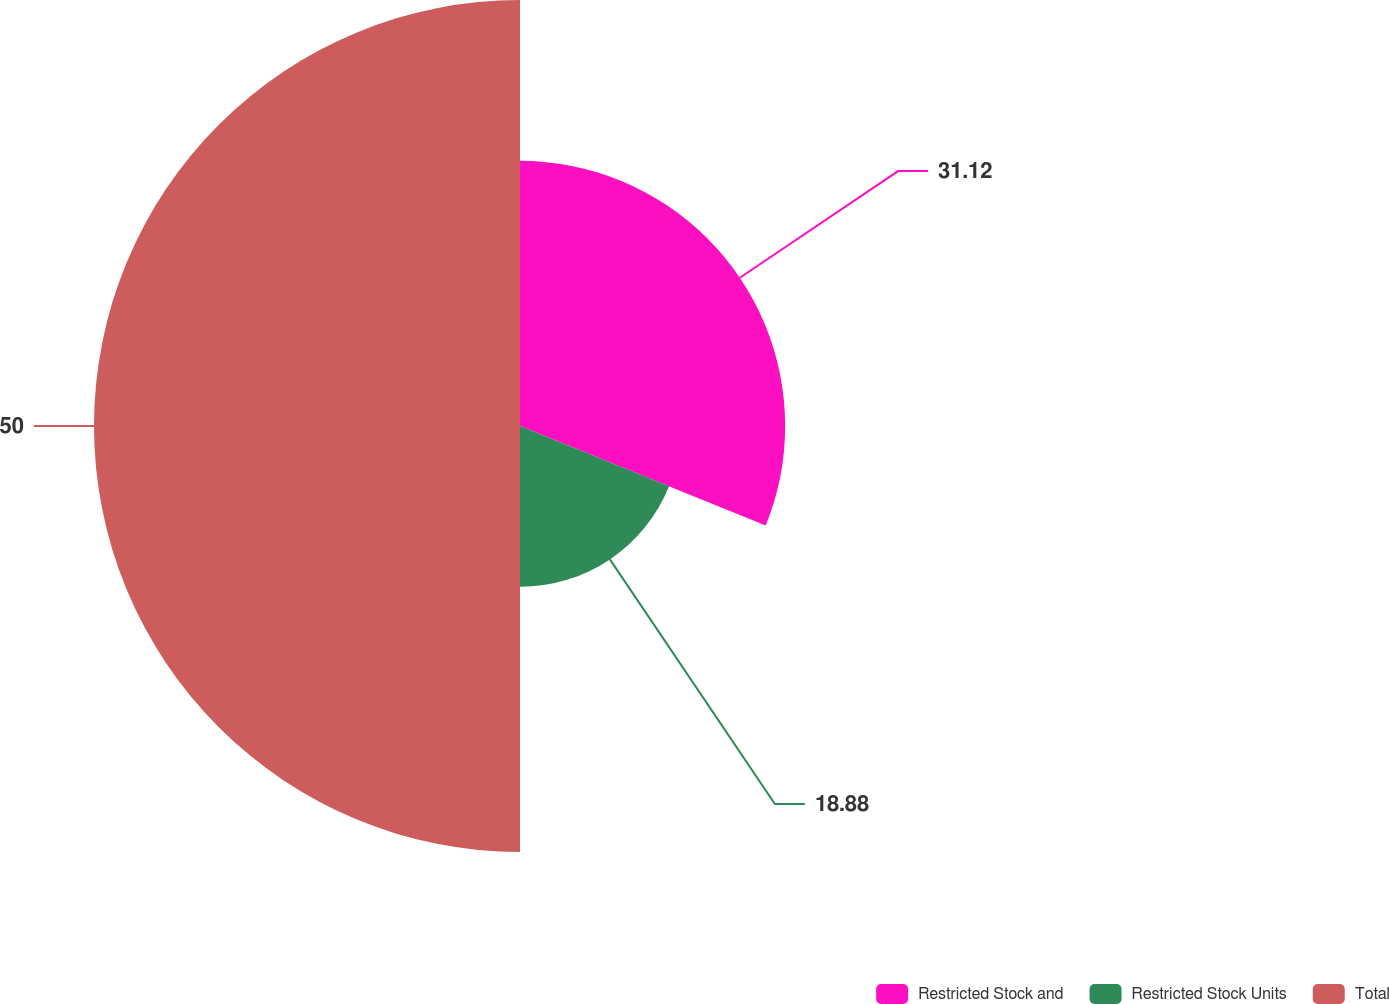<chart> <loc_0><loc_0><loc_500><loc_500><pie_chart><fcel>Restricted Stock and<fcel>Restricted Stock Units<fcel>Total<nl><fcel>31.12%<fcel>18.88%<fcel>50.0%<nl></chart> 